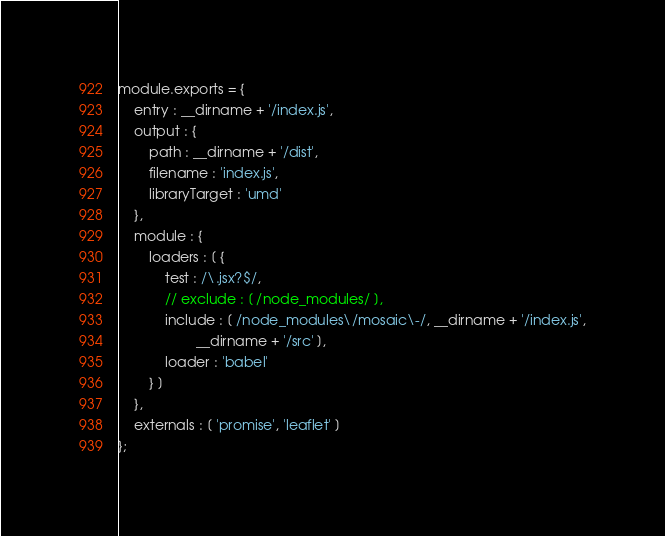<code> <loc_0><loc_0><loc_500><loc_500><_JavaScript_>module.exports = {
    entry : __dirname + '/index.js',
    output : {
        path : __dirname + '/dist',
        filename : 'index.js',
        libraryTarget : 'umd'
    },
    module : {
        loaders : [ {
            test : /\.jsx?$/,
            // exclude : [ /node_modules/ ],
            include : [ /node_modules\/mosaic\-/, __dirname + '/index.js',
                    __dirname + '/src' ],
            loader : 'babel'
        } ]
    },
    externals : [ 'promise', 'leaflet' ]
};
</code> 